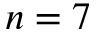Convert formula to latex. <formula><loc_0><loc_0><loc_500><loc_500>n = 7</formula> 